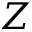<formula> <loc_0><loc_0><loc_500><loc_500>Z</formula> 